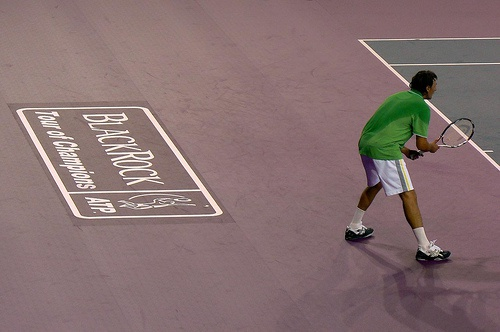Describe the objects in this image and their specific colors. I can see people in gray, darkgreen, black, and darkgray tones and tennis racket in gray, black, and lightgray tones in this image. 